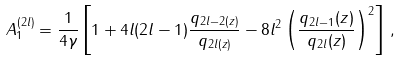<formula> <loc_0><loc_0><loc_500><loc_500>A _ { 1 } ^ { ( 2 l ) } = \frac { 1 } { 4 \gamma } \left [ 1 + 4 l ( 2 l - 1 ) \frac { q _ { 2 l - 2 ( z ) } } { q _ { 2 l ( z ) } } - 8 l ^ { 2 } \left ( \frac { q _ { 2 l - 1 } ( z ) } { q _ { 2 l } ( z ) } \right ) ^ { 2 } \right ] \, ,</formula> 